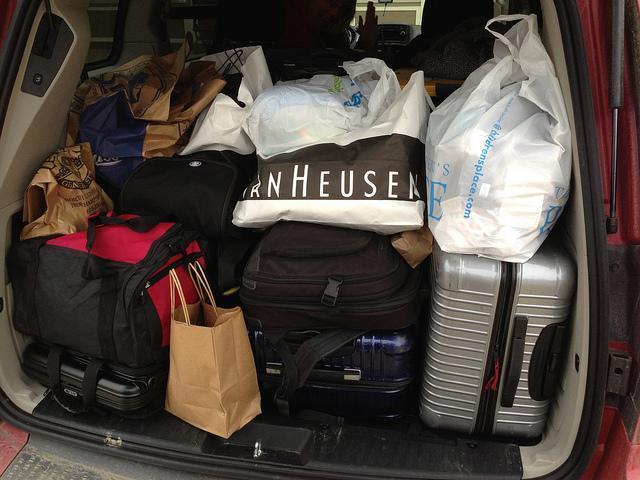How many handbags are there?
Give a very brief answer. 3. How many suitcases are in the photo?
Give a very brief answer. 5. How many backpacks are there?
Give a very brief answer. 1. How many green bikes are in the picture?
Give a very brief answer. 0. 